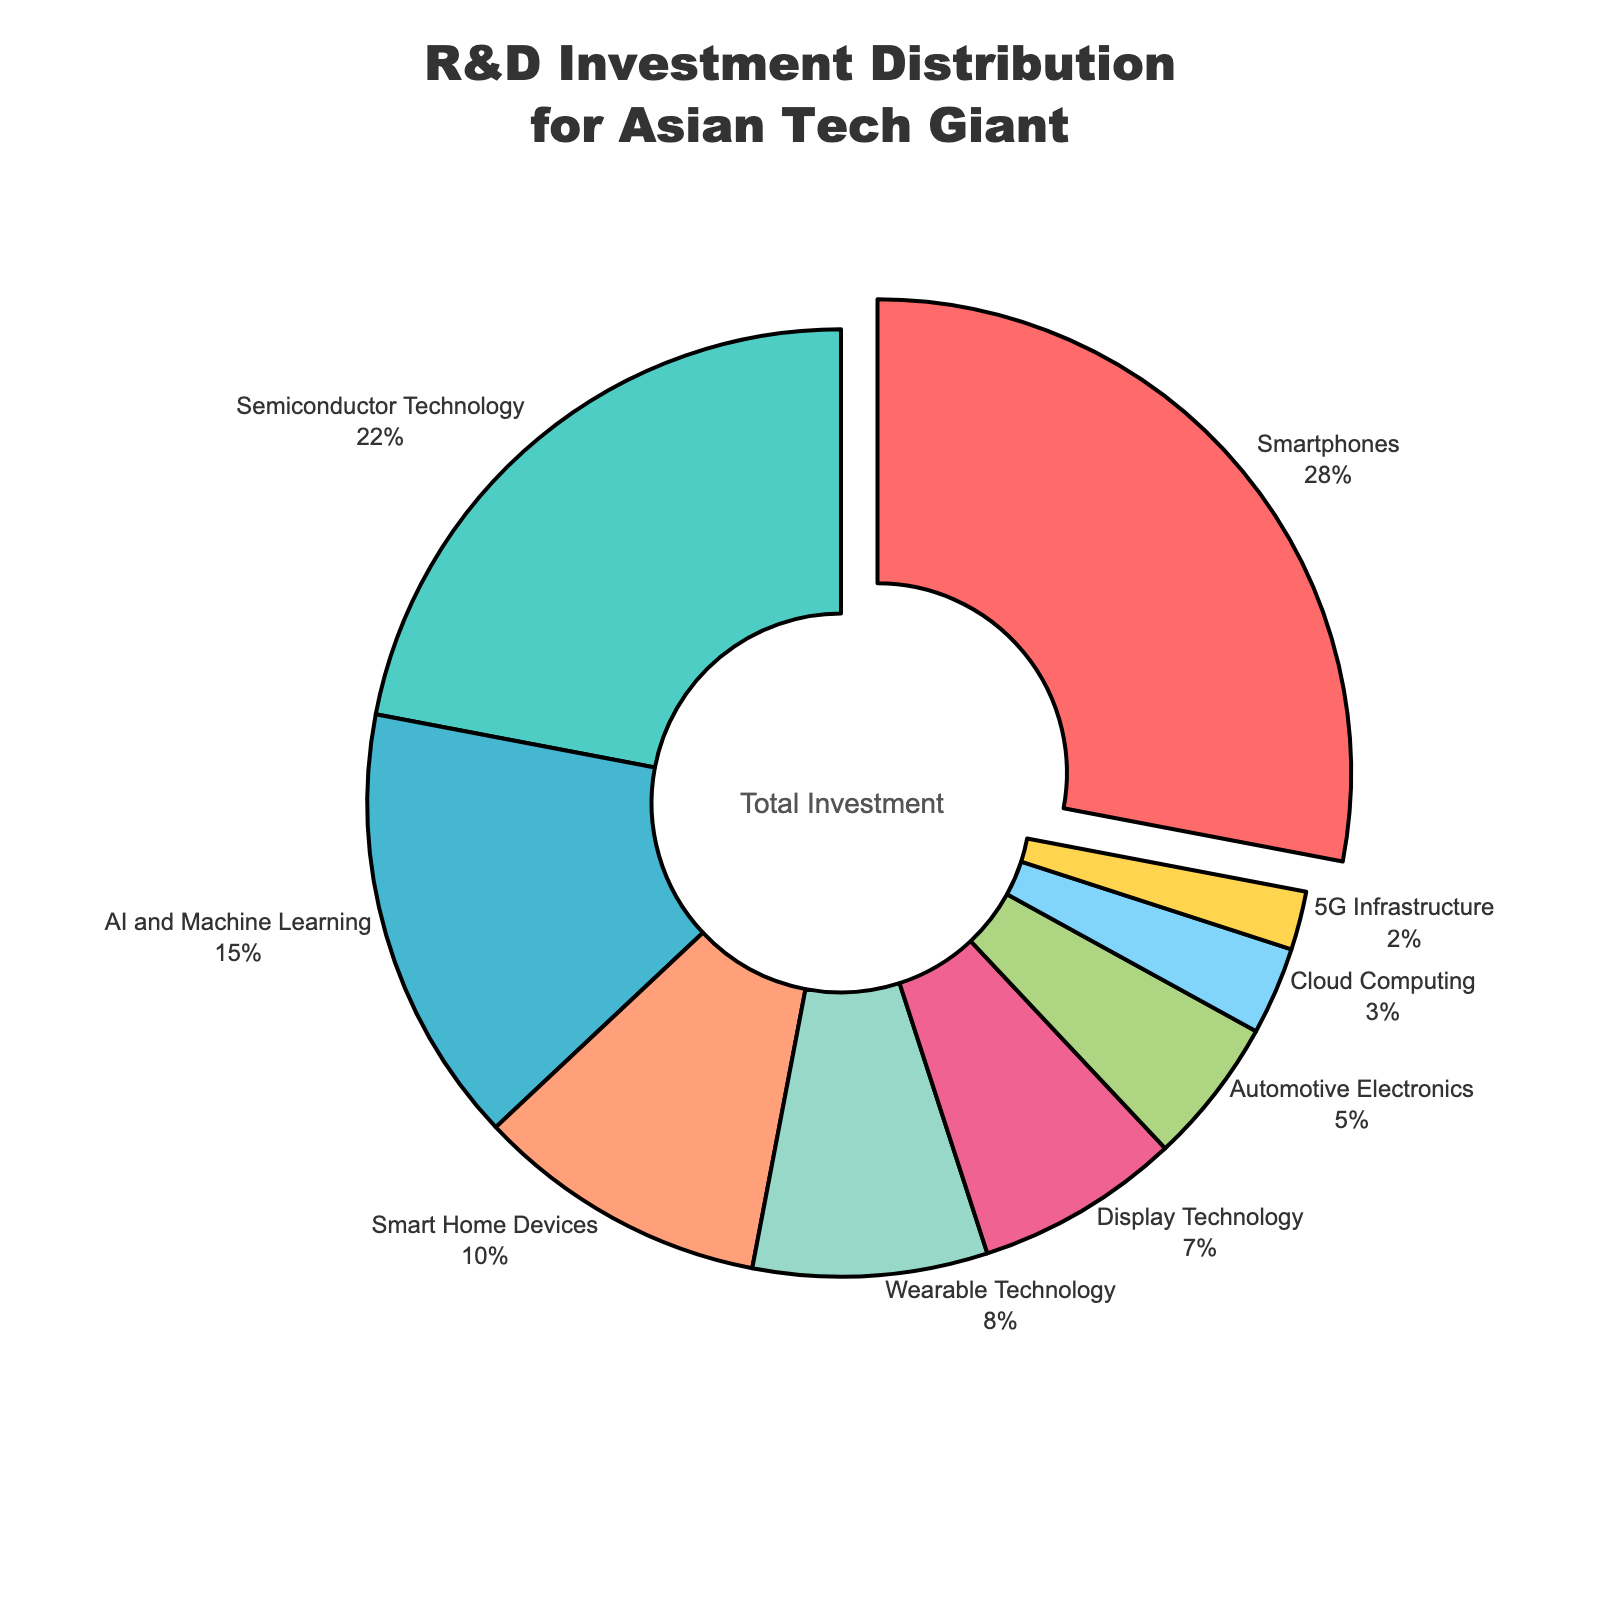Which product category receives the highest R&D investment? The product category that receives the highest R&D investment is identified by the largest percentage value in the figure.
Answer: Smartphones What is the combined R&D investment percentage for Semiconductor Technology and AI and Machine Learning? Add the R&D investment percentages for Semiconductor Technology (22%) and AI and Machine Learning (15%). 22% + 15% = 37%
Answer: 37% Which product category receives the least R&D investment? The product category that receives the least R&D investment is identified by the smallest percentage value in the figure.
Answer: 5G Infrastructure How much more R&D investment do Smartphones receive compared to Wearable Technology? Subtract the R&D investment percentage of Wearable Technology (8%) from that of Smartphones (28%). 28% - 8% = 20%
Answer: 20% What is the average R&D investment percentage for Smart Home Devices, Wearable Technology, and Display Technology? Add the R&D investment percentages for Smart Home Devices (10%), Wearable Technology (8%), and Display Technology (7%) and divide by 3. (10% + 8% + 7%) / 3 = 25% / 3 ≈ 8.33%
Answer: 8.33% Which categories together cover exactly half of the total R&D investment? Sum the R&D investment percentages of categories until they reach approximately 50%. Smartphones (28%) + Semiconductor Technology (22%) = 50%
Answer: Smartphones and Semiconductor Technology What is the difference between the R&D investment percentages of Automotive Electronics and Cloud Computing? Subtract the R&D investment percentage of Cloud Computing (3%) from that of Automotive Electronics (5%). 5% - 3% = 2%
Answer: 2% Which product category is represented by the color blue? Identify the product category associated with the color blue in the pie chart.
Answer: Display Technology If the R&D investment for 5G Infrastructure doubled, what would the new investment percentage be? Double the current R&D investment percentage of 5G Infrastructure (2%). 2% * 2 = 4%
Answer: 4% How much combined R&D investment is allocated to AI and Machine Learning and Cloud Computing? Add the R&D investment percentages for AI and Machine Learning (15%) and Cloud Computing (3%). 15% + 3% = 18%
Answer: 18% 